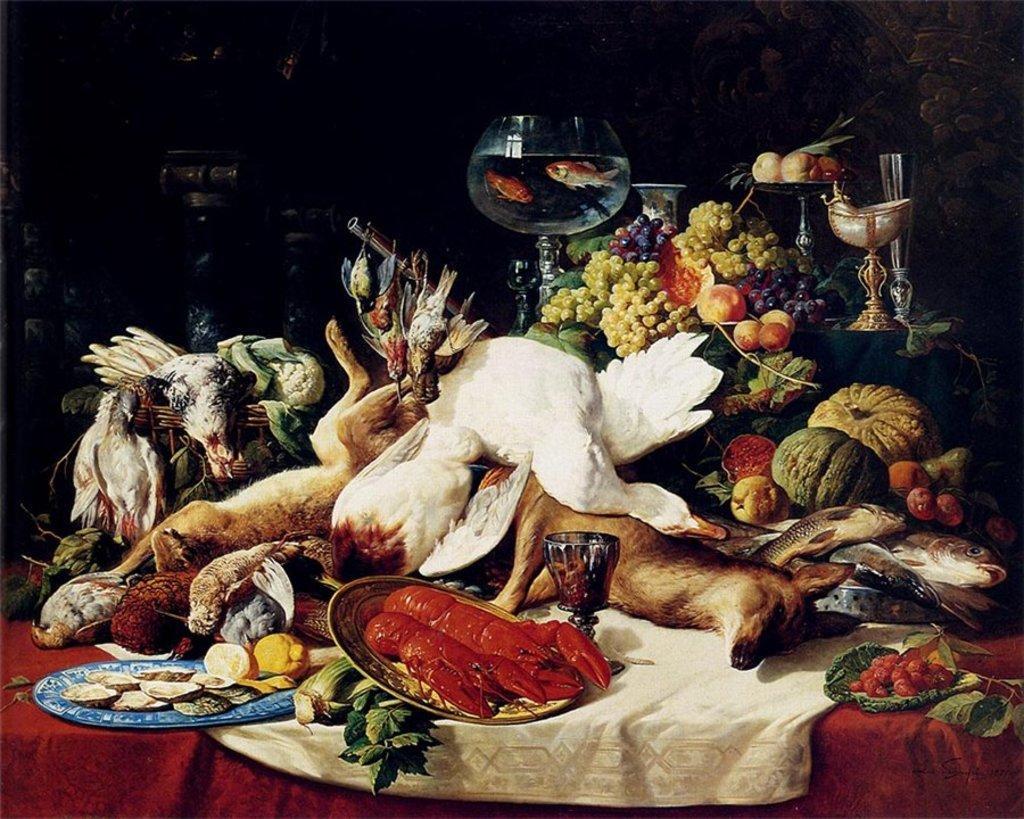Can you describe this image briefly? In this image I can see depiction picture where I can see number of dead animals, few plates, few glasses, fruits, vegetables and few clothes. 